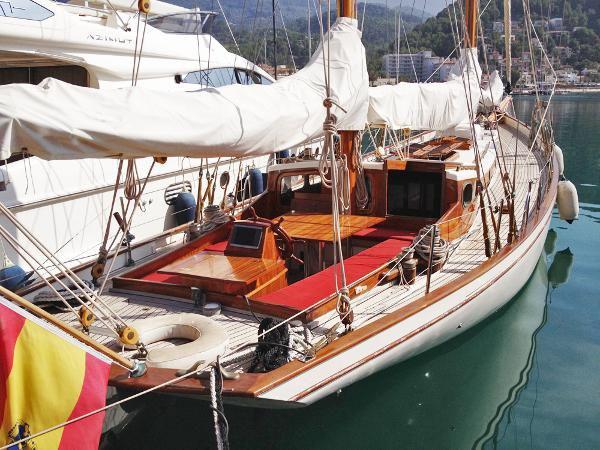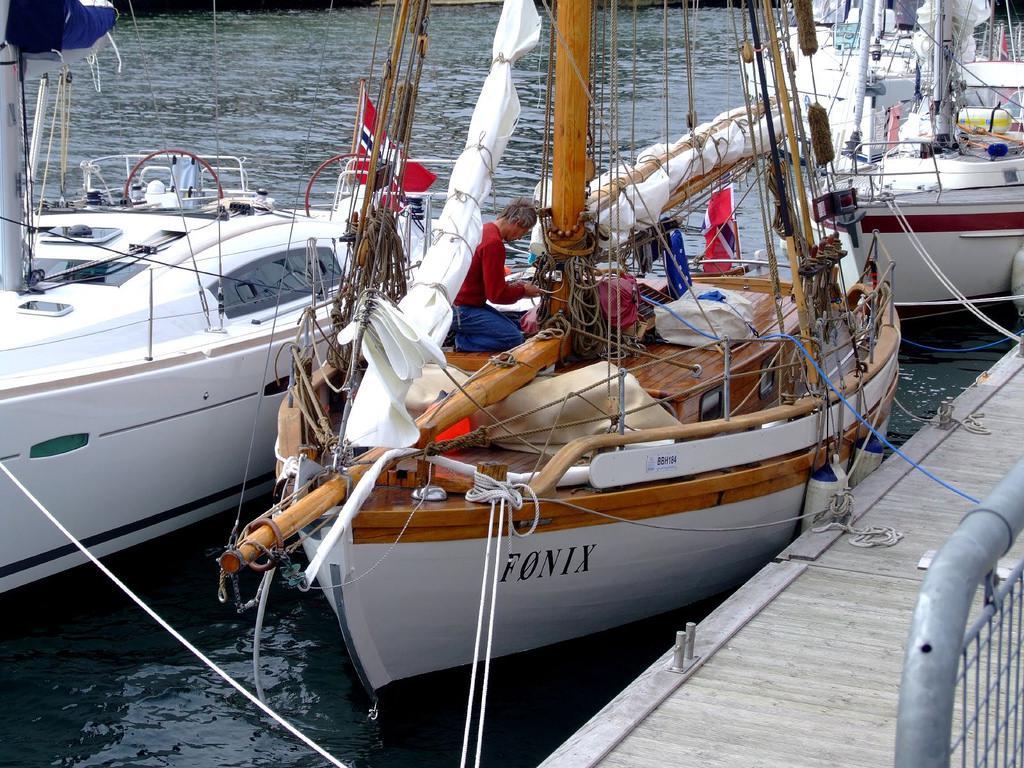The first image is the image on the left, the second image is the image on the right. Assess this claim about the two images: "Atleast one of the pictures doesn't have a white boat.". Correct or not? Answer yes or no. No. The first image is the image on the left, the second image is the image on the right. Given the left and right images, does the statement "In one image there is a boat that is in harbor with the dock on the right side of the image." hold true? Answer yes or no. Yes. 